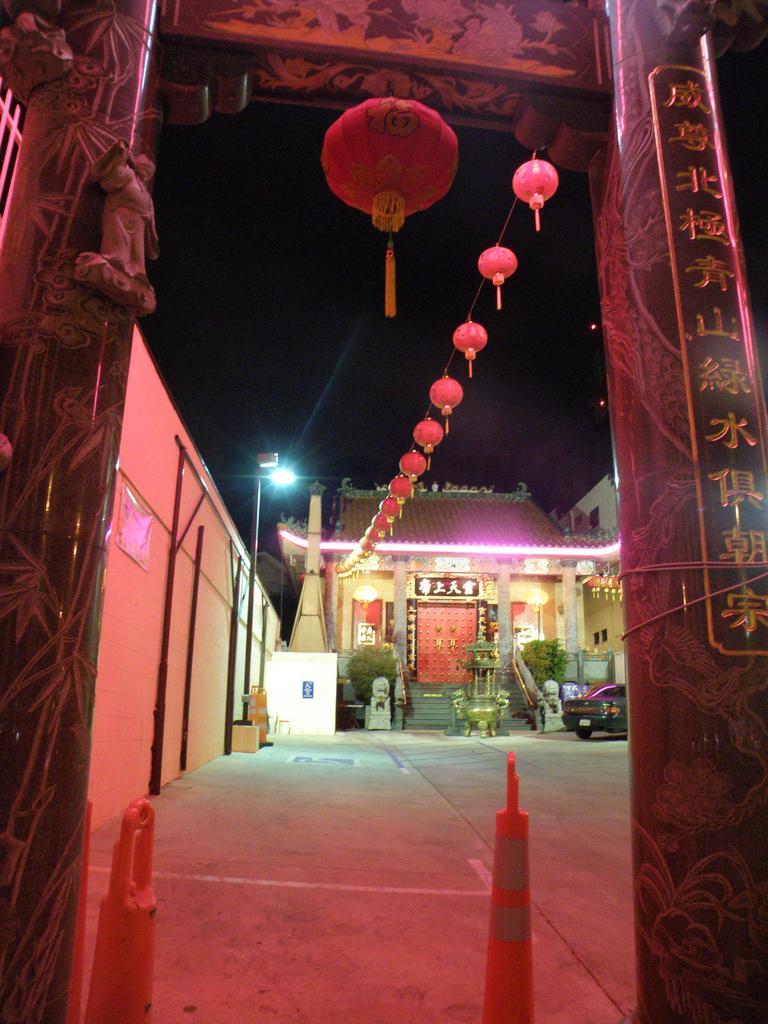In one or two sentences, can you explain what this image depicts? In this image we can see pillars. On the pillar there is text. Another pillar there is sculpture. Also there are decorations. On the left side there is a wall. And there is a light pole. In the back there is a building with steps and doors. Also there are plants. And there is an object in front of the building. And there is a car. In the background it is dark. And we can see lights. 